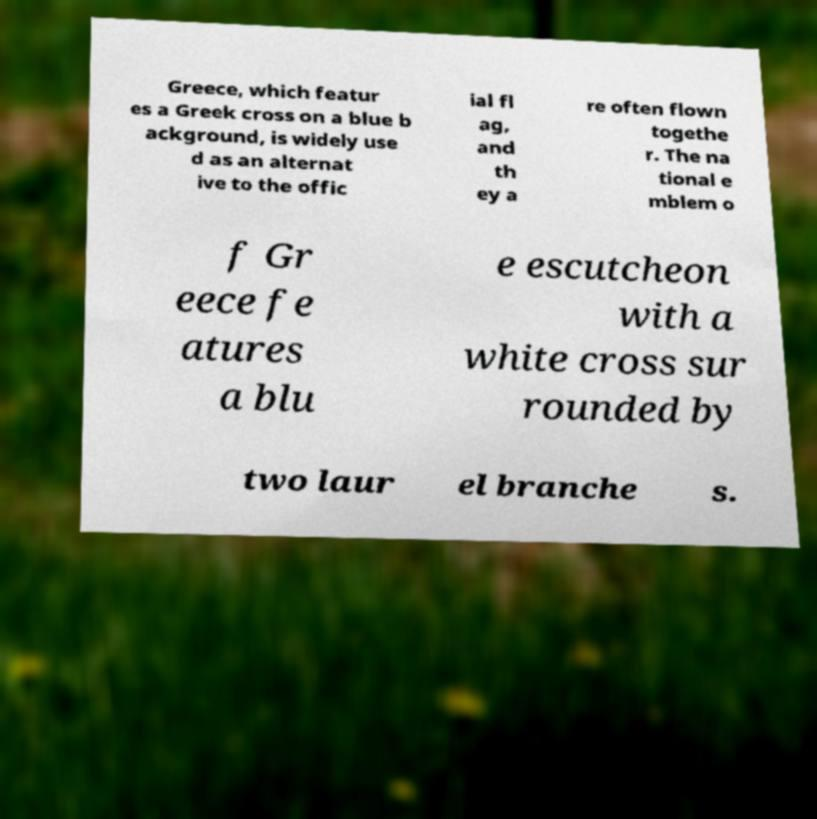Can you accurately transcribe the text from the provided image for me? Greece, which featur es a Greek cross on a blue b ackground, is widely use d as an alternat ive to the offic ial fl ag, and th ey a re often flown togethe r. The na tional e mblem o f Gr eece fe atures a blu e escutcheon with a white cross sur rounded by two laur el branche s. 